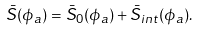Convert formula to latex. <formula><loc_0><loc_0><loc_500><loc_500>\bar { S } ( \phi _ { a } ) = \bar { S } _ { 0 } ( \phi _ { a } ) + \bar { S } _ { i n t } ( \phi _ { a } ) .</formula> 